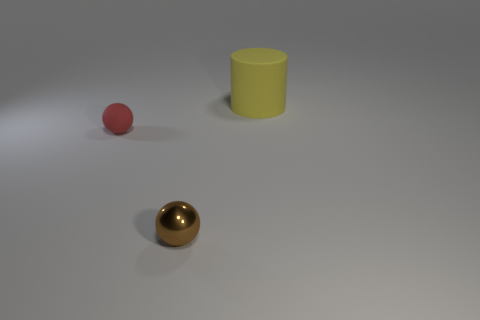There is a thing that is behind the tiny red object; what is its shape?
Your answer should be very brief. Cylinder. What number of small green objects are there?
Give a very brief answer. 0. There is a small sphere that is the same material as the yellow object; what is its color?
Keep it short and to the point. Red. How many big objects are either purple rubber things or brown shiny spheres?
Offer a very short reply. 0. There is a tiny shiny object; what number of yellow cylinders are left of it?
Ensure brevity in your answer.  0. What is the color of the metallic object that is the same shape as the tiny red rubber object?
Your answer should be compact. Brown. How many shiny objects are either red objects or tiny blue balls?
Offer a terse response. 0. There is a tiny ball that is in front of the sphere behind the brown shiny sphere; are there any large things that are left of it?
Offer a very short reply. No. What color is the metal sphere?
Keep it short and to the point. Brown. There is a rubber object on the left side of the big cylinder; is its shape the same as the small brown shiny thing?
Offer a very short reply. Yes. 